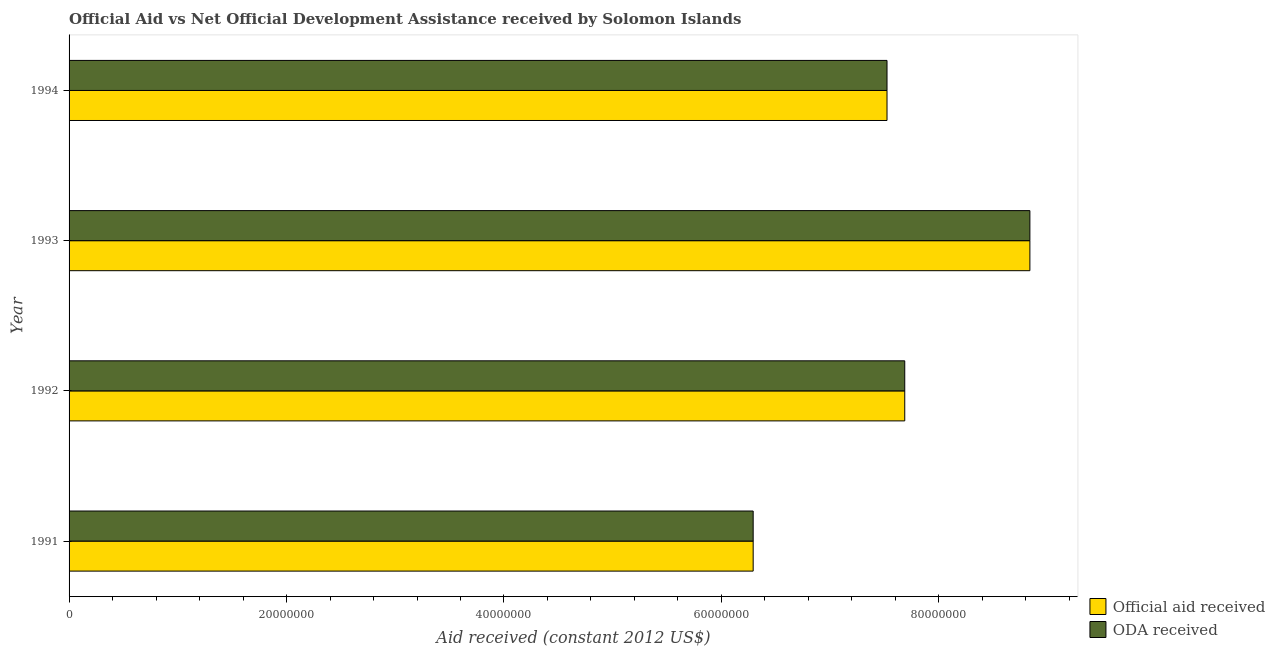How many different coloured bars are there?
Your answer should be compact. 2. How many groups of bars are there?
Your answer should be compact. 4. Are the number of bars on each tick of the Y-axis equal?
Your answer should be compact. Yes. What is the oda received in 1993?
Provide a short and direct response. 8.84e+07. Across all years, what is the maximum official aid received?
Your response must be concise. 8.84e+07. Across all years, what is the minimum oda received?
Your answer should be compact. 6.29e+07. What is the total official aid received in the graph?
Your answer should be very brief. 3.03e+08. What is the difference between the official aid received in 1991 and that in 1993?
Your answer should be compact. -2.54e+07. What is the difference between the oda received in 1992 and the official aid received in 1993?
Ensure brevity in your answer.  -1.15e+07. What is the average oda received per year?
Provide a short and direct response. 7.58e+07. In how many years, is the oda received greater than 80000000 US$?
Your answer should be compact. 1. What is the ratio of the official aid received in 1992 to that in 1993?
Keep it short and to the point. 0.87. Is the oda received in 1991 less than that in 1993?
Ensure brevity in your answer.  Yes. What is the difference between the highest and the second highest official aid received?
Your answer should be compact. 1.15e+07. What is the difference between the highest and the lowest oda received?
Your answer should be compact. 2.54e+07. In how many years, is the official aid received greater than the average official aid received taken over all years?
Your response must be concise. 2. What does the 1st bar from the top in 1991 represents?
Keep it short and to the point. ODA received. What does the 2nd bar from the bottom in 1992 represents?
Offer a very short reply. ODA received. How many bars are there?
Your response must be concise. 8. Are all the bars in the graph horizontal?
Your answer should be compact. Yes. What is the title of the graph?
Keep it short and to the point. Official Aid vs Net Official Development Assistance received by Solomon Islands . Does "Passenger Transport Items" appear as one of the legend labels in the graph?
Provide a succinct answer. No. What is the label or title of the X-axis?
Give a very brief answer. Aid received (constant 2012 US$). What is the label or title of the Y-axis?
Keep it short and to the point. Year. What is the Aid received (constant 2012 US$) in Official aid received in 1991?
Give a very brief answer. 6.29e+07. What is the Aid received (constant 2012 US$) in ODA received in 1991?
Your answer should be compact. 6.29e+07. What is the Aid received (constant 2012 US$) in Official aid received in 1992?
Your response must be concise. 7.69e+07. What is the Aid received (constant 2012 US$) in ODA received in 1992?
Offer a terse response. 7.69e+07. What is the Aid received (constant 2012 US$) of Official aid received in 1993?
Offer a terse response. 8.84e+07. What is the Aid received (constant 2012 US$) of ODA received in 1993?
Give a very brief answer. 8.84e+07. What is the Aid received (constant 2012 US$) in Official aid received in 1994?
Give a very brief answer. 7.52e+07. What is the Aid received (constant 2012 US$) of ODA received in 1994?
Keep it short and to the point. 7.52e+07. Across all years, what is the maximum Aid received (constant 2012 US$) of Official aid received?
Your answer should be compact. 8.84e+07. Across all years, what is the maximum Aid received (constant 2012 US$) of ODA received?
Provide a succinct answer. 8.84e+07. Across all years, what is the minimum Aid received (constant 2012 US$) of Official aid received?
Your answer should be very brief. 6.29e+07. Across all years, what is the minimum Aid received (constant 2012 US$) of ODA received?
Ensure brevity in your answer.  6.29e+07. What is the total Aid received (constant 2012 US$) in Official aid received in the graph?
Offer a terse response. 3.03e+08. What is the total Aid received (constant 2012 US$) in ODA received in the graph?
Your answer should be compact. 3.03e+08. What is the difference between the Aid received (constant 2012 US$) in Official aid received in 1991 and that in 1992?
Your response must be concise. -1.39e+07. What is the difference between the Aid received (constant 2012 US$) of ODA received in 1991 and that in 1992?
Offer a very short reply. -1.39e+07. What is the difference between the Aid received (constant 2012 US$) in Official aid received in 1991 and that in 1993?
Offer a very short reply. -2.54e+07. What is the difference between the Aid received (constant 2012 US$) in ODA received in 1991 and that in 1993?
Your response must be concise. -2.54e+07. What is the difference between the Aid received (constant 2012 US$) in Official aid received in 1991 and that in 1994?
Offer a terse response. -1.23e+07. What is the difference between the Aid received (constant 2012 US$) of ODA received in 1991 and that in 1994?
Your response must be concise. -1.23e+07. What is the difference between the Aid received (constant 2012 US$) in Official aid received in 1992 and that in 1993?
Make the answer very short. -1.15e+07. What is the difference between the Aid received (constant 2012 US$) of ODA received in 1992 and that in 1993?
Provide a succinct answer. -1.15e+07. What is the difference between the Aid received (constant 2012 US$) in Official aid received in 1992 and that in 1994?
Ensure brevity in your answer.  1.63e+06. What is the difference between the Aid received (constant 2012 US$) of ODA received in 1992 and that in 1994?
Give a very brief answer. 1.63e+06. What is the difference between the Aid received (constant 2012 US$) in Official aid received in 1993 and that in 1994?
Your answer should be very brief. 1.31e+07. What is the difference between the Aid received (constant 2012 US$) in ODA received in 1993 and that in 1994?
Your answer should be compact. 1.31e+07. What is the difference between the Aid received (constant 2012 US$) of Official aid received in 1991 and the Aid received (constant 2012 US$) of ODA received in 1992?
Your answer should be compact. -1.39e+07. What is the difference between the Aid received (constant 2012 US$) in Official aid received in 1991 and the Aid received (constant 2012 US$) in ODA received in 1993?
Your answer should be very brief. -2.54e+07. What is the difference between the Aid received (constant 2012 US$) in Official aid received in 1991 and the Aid received (constant 2012 US$) in ODA received in 1994?
Your response must be concise. -1.23e+07. What is the difference between the Aid received (constant 2012 US$) of Official aid received in 1992 and the Aid received (constant 2012 US$) of ODA received in 1993?
Your answer should be very brief. -1.15e+07. What is the difference between the Aid received (constant 2012 US$) in Official aid received in 1992 and the Aid received (constant 2012 US$) in ODA received in 1994?
Provide a succinct answer. 1.63e+06. What is the difference between the Aid received (constant 2012 US$) in Official aid received in 1993 and the Aid received (constant 2012 US$) in ODA received in 1994?
Provide a succinct answer. 1.31e+07. What is the average Aid received (constant 2012 US$) of Official aid received per year?
Keep it short and to the point. 7.58e+07. What is the average Aid received (constant 2012 US$) in ODA received per year?
Your answer should be compact. 7.58e+07. In the year 1993, what is the difference between the Aid received (constant 2012 US$) in Official aid received and Aid received (constant 2012 US$) in ODA received?
Provide a succinct answer. 0. In the year 1994, what is the difference between the Aid received (constant 2012 US$) of Official aid received and Aid received (constant 2012 US$) of ODA received?
Ensure brevity in your answer.  0. What is the ratio of the Aid received (constant 2012 US$) in Official aid received in 1991 to that in 1992?
Offer a terse response. 0.82. What is the ratio of the Aid received (constant 2012 US$) in ODA received in 1991 to that in 1992?
Offer a very short reply. 0.82. What is the ratio of the Aid received (constant 2012 US$) of Official aid received in 1991 to that in 1993?
Give a very brief answer. 0.71. What is the ratio of the Aid received (constant 2012 US$) in ODA received in 1991 to that in 1993?
Provide a short and direct response. 0.71. What is the ratio of the Aid received (constant 2012 US$) of Official aid received in 1991 to that in 1994?
Provide a short and direct response. 0.84. What is the ratio of the Aid received (constant 2012 US$) in ODA received in 1991 to that in 1994?
Offer a very short reply. 0.84. What is the ratio of the Aid received (constant 2012 US$) in Official aid received in 1992 to that in 1993?
Keep it short and to the point. 0.87. What is the ratio of the Aid received (constant 2012 US$) in ODA received in 1992 to that in 1993?
Keep it short and to the point. 0.87. What is the ratio of the Aid received (constant 2012 US$) of Official aid received in 1992 to that in 1994?
Your answer should be compact. 1.02. What is the ratio of the Aid received (constant 2012 US$) in ODA received in 1992 to that in 1994?
Give a very brief answer. 1.02. What is the ratio of the Aid received (constant 2012 US$) in Official aid received in 1993 to that in 1994?
Keep it short and to the point. 1.17. What is the ratio of the Aid received (constant 2012 US$) in ODA received in 1993 to that in 1994?
Offer a terse response. 1.17. What is the difference between the highest and the second highest Aid received (constant 2012 US$) in Official aid received?
Provide a short and direct response. 1.15e+07. What is the difference between the highest and the second highest Aid received (constant 2012 US$) of ODA received?
Your answer should be very brief. 1.15e+07. What is the difference between the highest and the lowest Aid received (constant 2012 US$) of Official aid received?
Provide a succinct answer. 2.54e+07. What is the difference between the highest and the lowest Aid received (constant 2012 US$) of ODA received?
Your answer should be compact. 2.54e+07. 